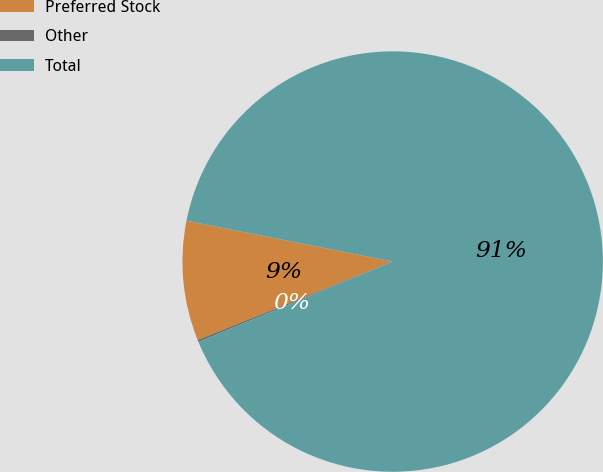<chart> <loc_0><loc_0><loc_500><loc_500><pie_chart><fcel>Preferred Stock<fcel>Other<fcel>Total<nl><fcel>9.2%<fcel>0.15%<fcel>90.65%<nl></chart> 